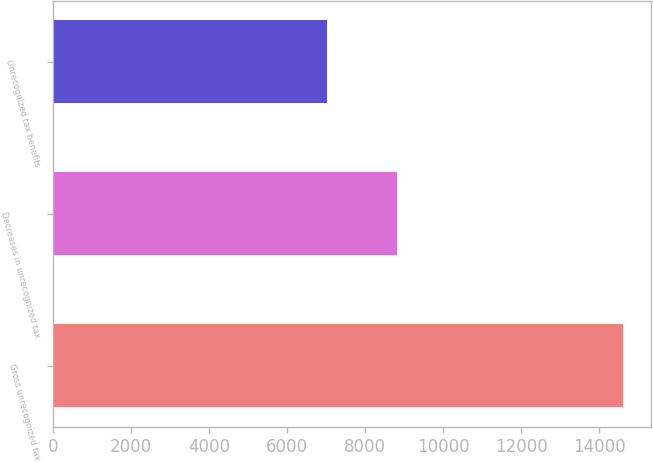Convert chart to OTSL. <chart><loc_0><loc_0><loc_500><loc_500><bar_chart><fcel>Gross unrecognized tax<fcel>Decreases in unrecognized tax<fcel>Unrecognized tax benefits<nl><fcel>14611<fcel>8815.9<fcel>7034<nl></chart> 